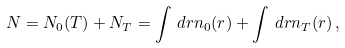<formula> <loc_0><loc_0><loc_500><loc_500>N = N _ { 0 } ( T ) + N _ { T } = \int \, d { r } n _ { 0 } ( { r } ) + \int \, d { r } n _ { T } ( { r } ) \, ,</formula> 